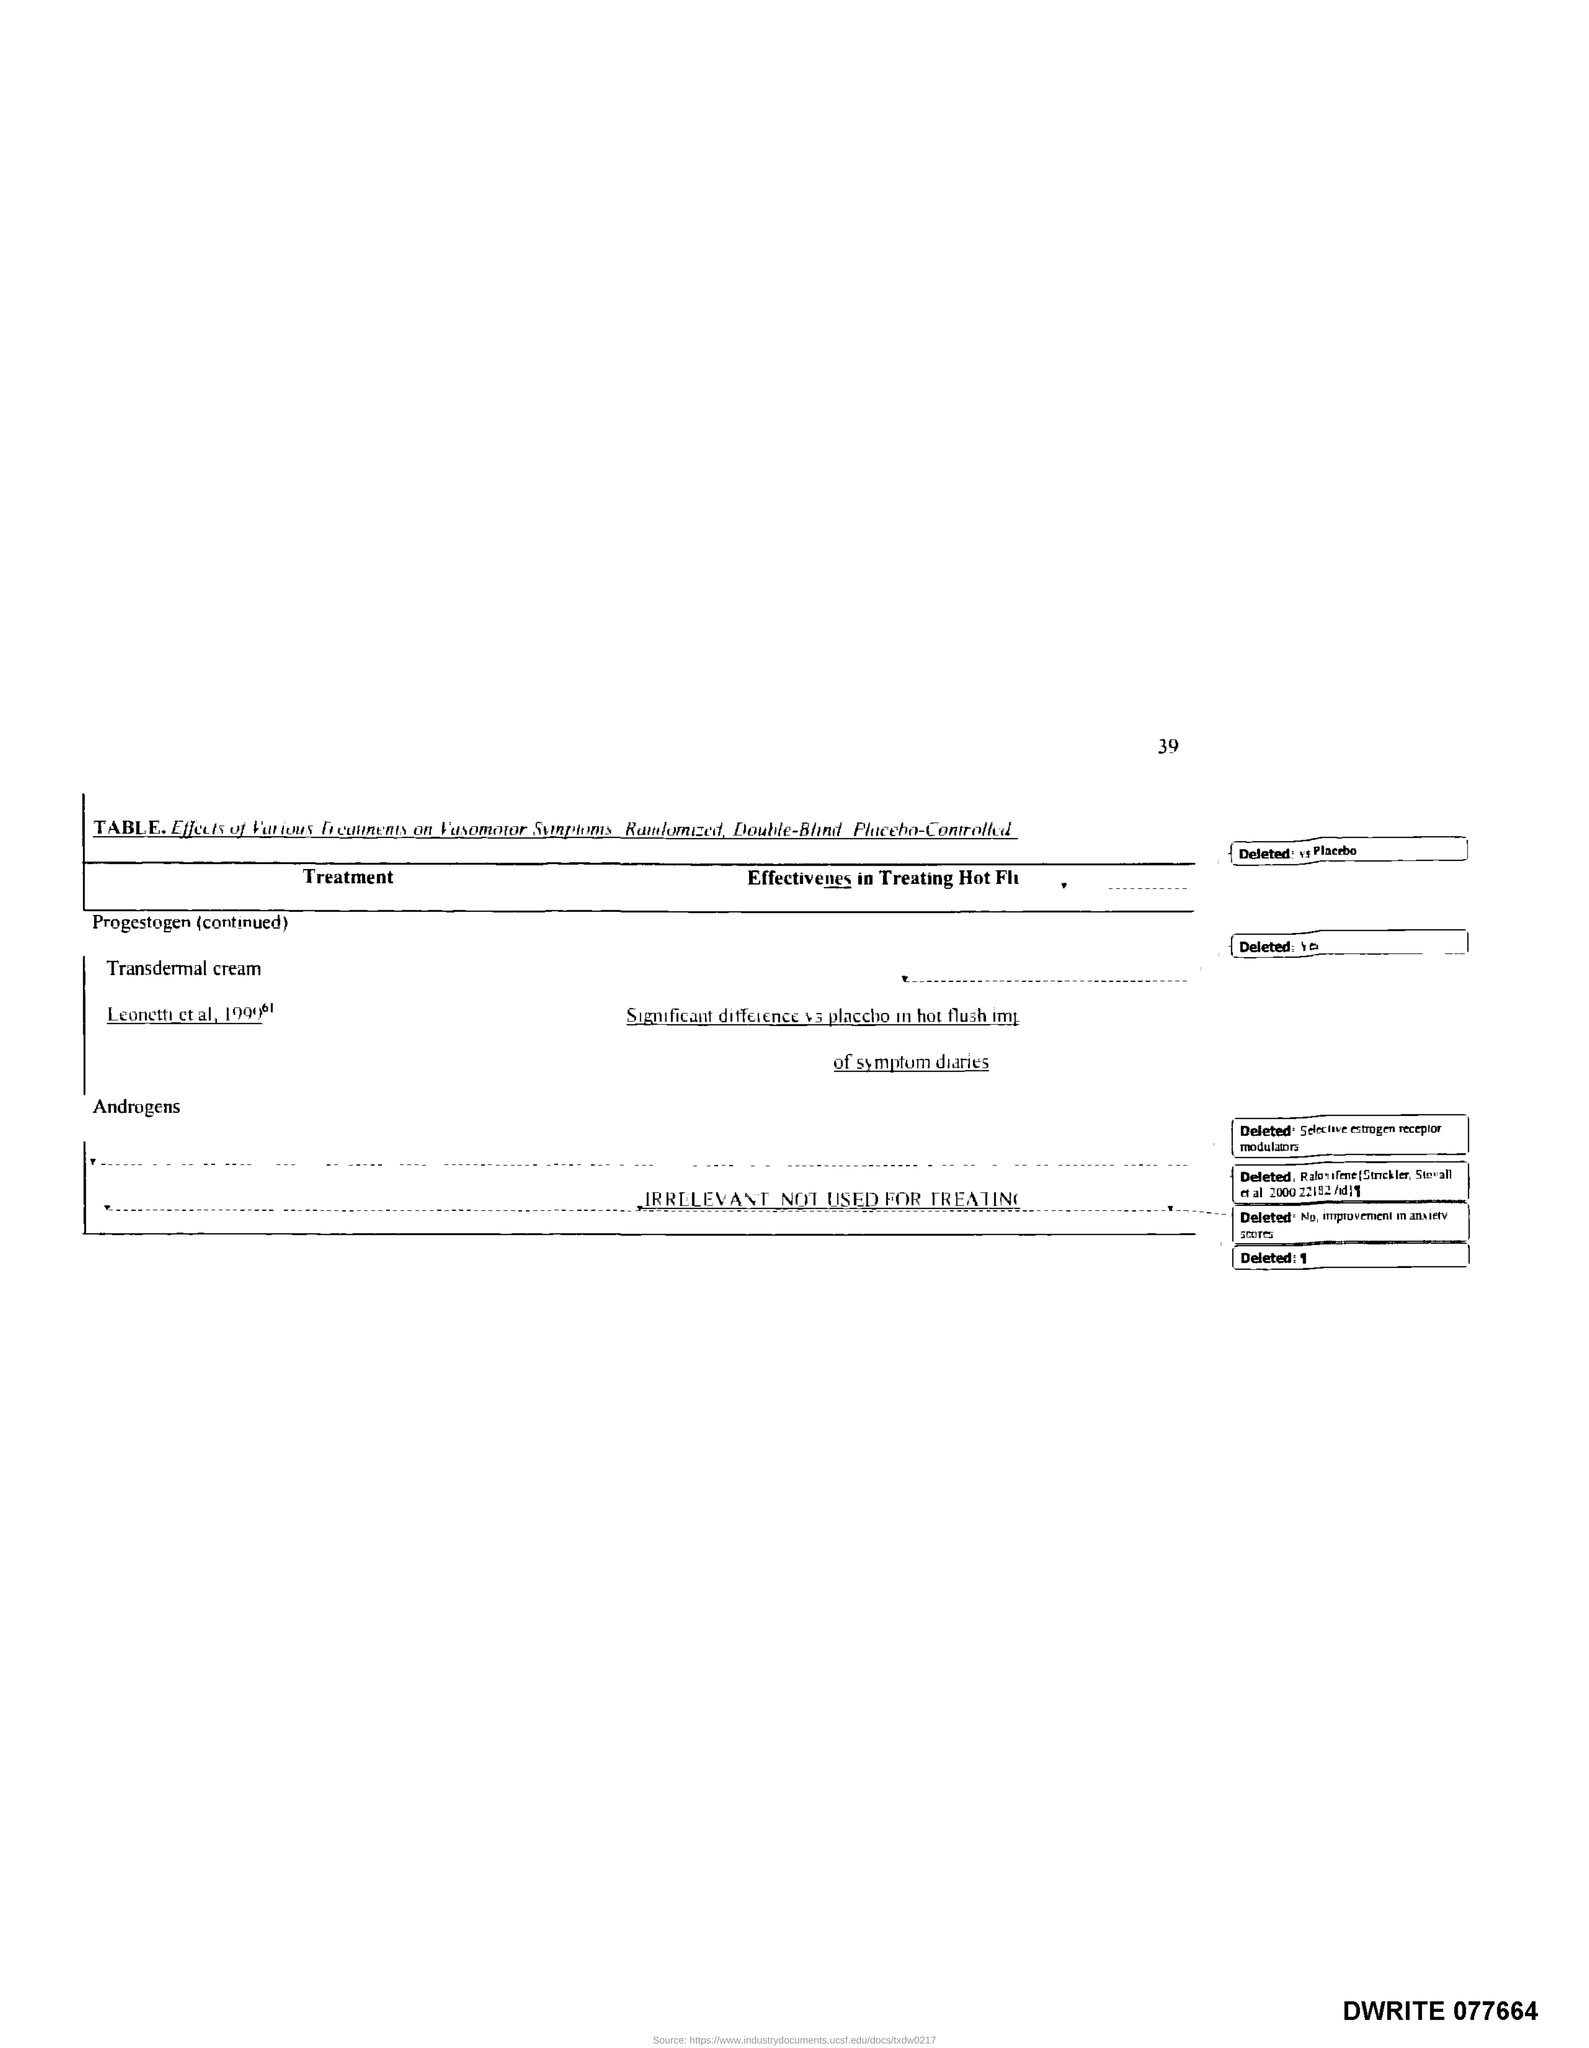Identify some key points in this picture. The title of the first column of the table is 'Treatment.' Page number 39 is being referenced. 